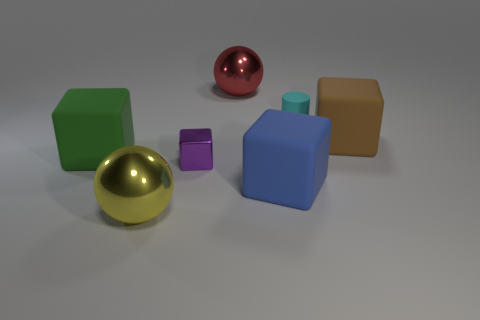How big is the block that is both behind the metallic cube and on the right side of the large yellow shiny thing?
Your answer should be very brief. Large. Are there any red objects that have the same shape as the yellow metallic thing?
Your answer should be very brief. Yes. What number of things are big objects or rubber things in front of the big green block?
Your answer should be very brief. 5. What number of other things are there of the same material as the big blue block
Make the answer very short. 3. How many things are either blue matte cubes or tiny blue matte balls?
Offer a very short reply. 1. Is the number of big red shiny balls behind the brown rubber object greater than the number of cyan rubber cylinders that are in front of the small shiny object?
Provide a short and direct response. Yes. There is a purple block that is behind the sphere that is in front of the metallic ball that is behind the cyan matte cylinder; what is its size?
Keep it short and to the point. Small. What color is the shiny object that is the same shape as the blue matte thing?
Your answer should be compact. Purple. Is the number of small purple objects in front of the cylinder greater than the number of tiny yellow shiny things?
Ensure brevity in your answer.  Yes. There is a large yellow shiny object; does it have the same shape as the shiny thing behind the large brown block?
Offer a terse response. Yes. 